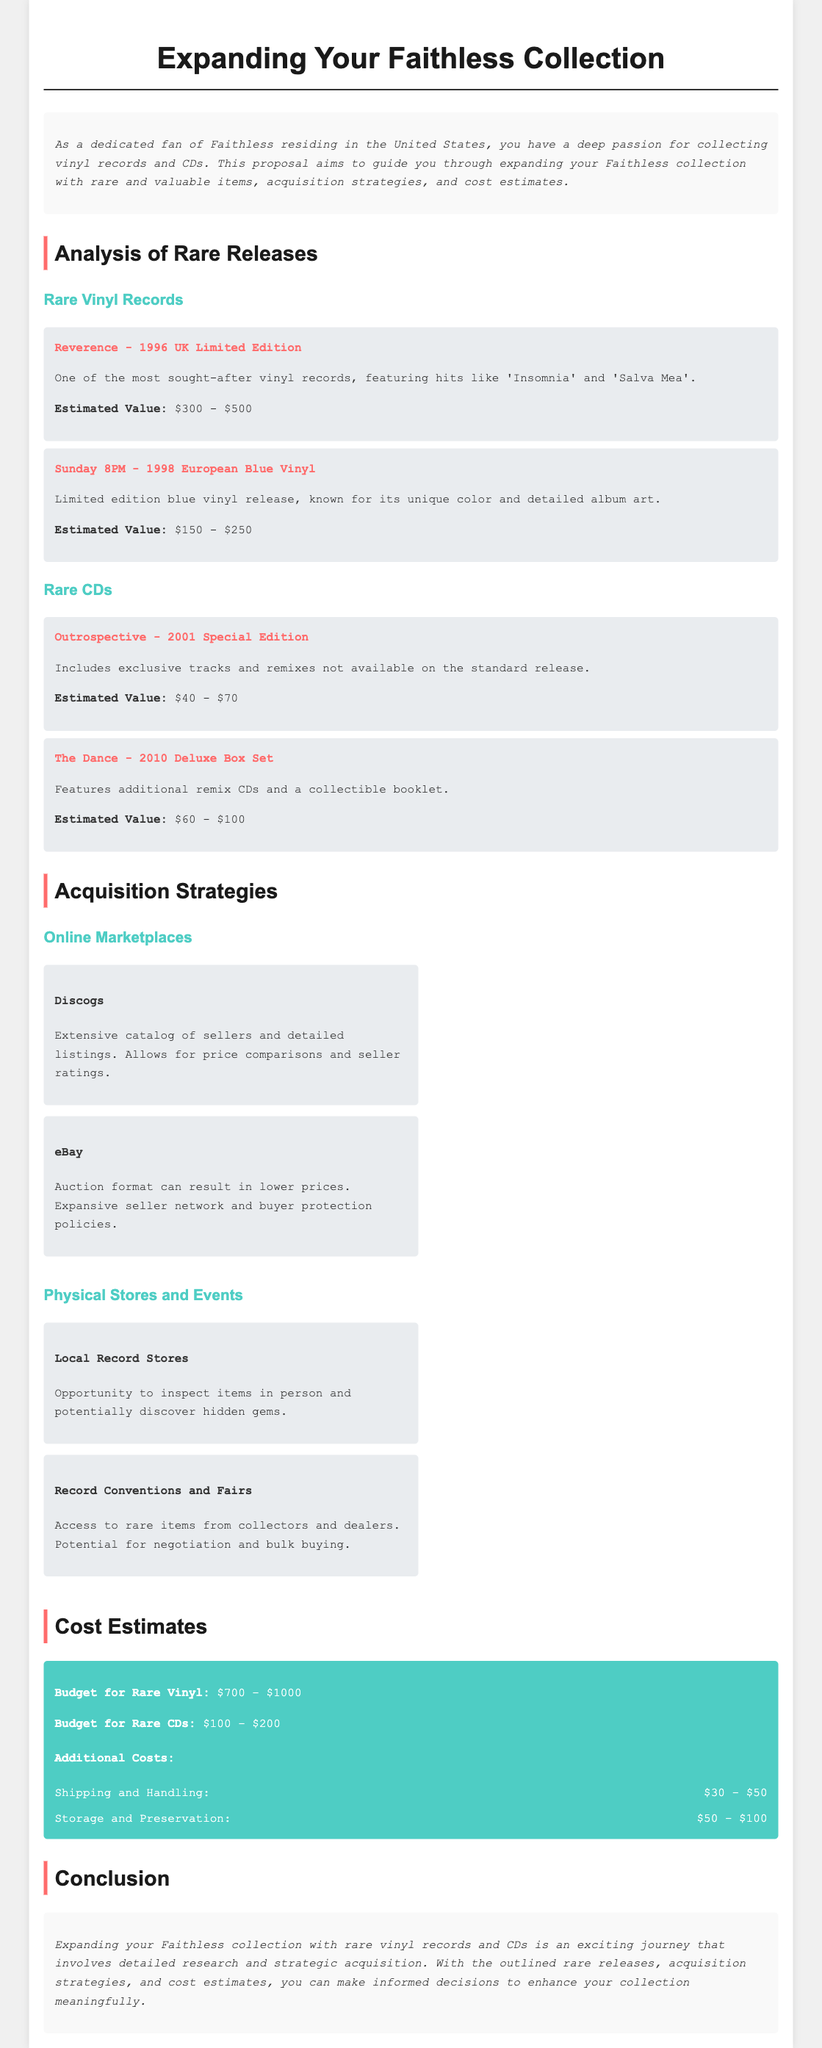What is the estimated value of the 1996 UK Limited Edition "Reverence"? The estimated value of the 1996 UK Limited Edition "Reverence" is mentioned as being between $300 - $500.
Answer: $300 - $500 Which online marketplace allows for price comparisons and seller ratings? The document states that Discogs has an extensive catalog of sellers and detailed listings, allowing for price comparisons and seller ratings.
Answer: Discogs What is the budget range for rare vinyl as outlined in the proposal? The budget for rare vinyl is indicated as between $700 - $1000.
Answer: $700 - $1000 What kind of vinyl is the 1998 European edition of "Sunday 8PM"? The document describes this item as a limited edition blue vinyl release.
Answer: Blue vinyl What type of events can provide access to rare items from collectors and dealers? The proposal mentions record conventions and fairs as events that offer access to rare items from collectors and dealers.
Answer: Record conventions and fairs Which special edition CD includes exclusive tracks not available on the standard release? Outrospective - 2001 Special Edition includes exclusive tracks and remixes not available on the standard release.
Answer: Outrospective - 2001 Special Edition What is the total estimated value range for rare CDs? The total estimated value range for rare CDs is stated as $100 - $200.
Answer: $100 - $200 How much is estimated for shipping and handling costs? The document mentions shipping and handling costs as estimated between $30 and $50.
Answer: $30 - $50 What is the main goal of the proposal? The main goal of the proposal is to guide you through expanding your Faithless collection.
Answer: Expanding your Faithless collection 